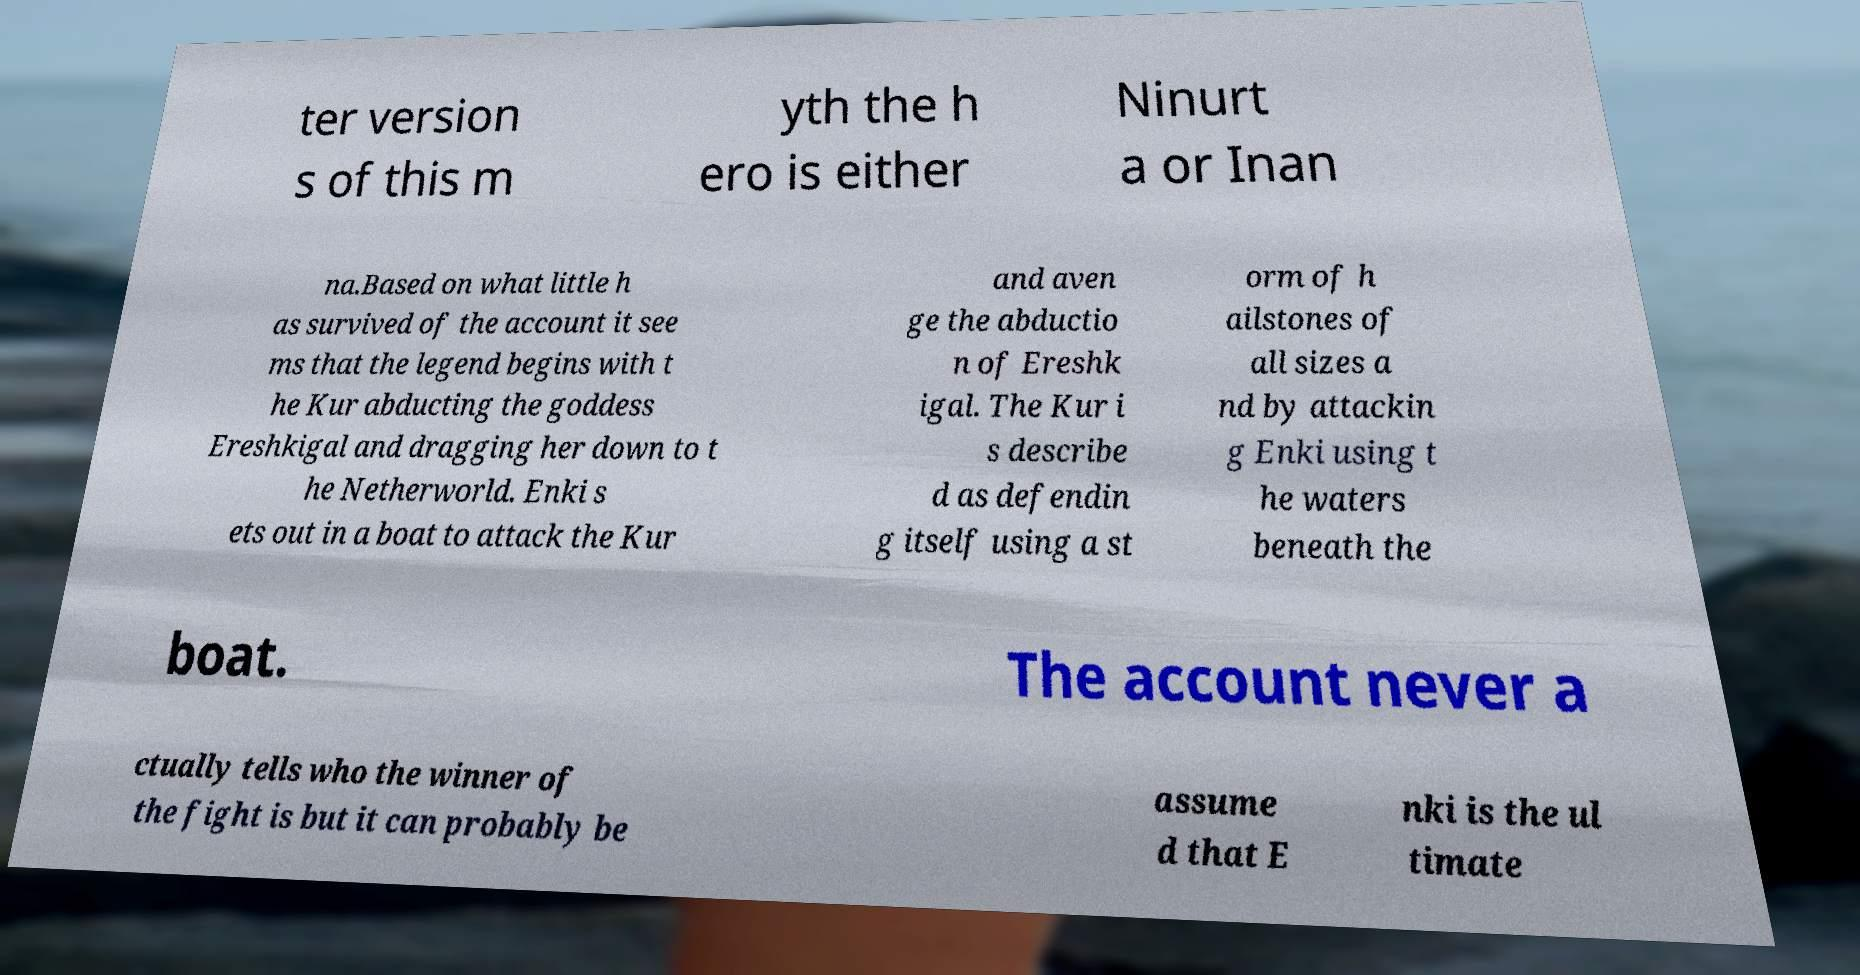Could you assist in decoding the text presented in this image and type it out clearly? ter version s of this m yth the h ero is either Ninurt a or Inan na.Based on what little h as survived of the account it see ms that the legend begins with t he Kur abducting the goddess Ereshkigal and dragging her down to t he Netherworld. Enki s ets out in a boat to attack the Kur and aven ge the abductio n of Ereshk igal. The Kur i s describe d as defendin g itself using a st orm of h ailstones of all sizes a nd by attackin g Enki using t he waters beneath the boat. The account never a ctually tells who the winner of the fight is but it can probably be assume d that E nki is the ul timate 